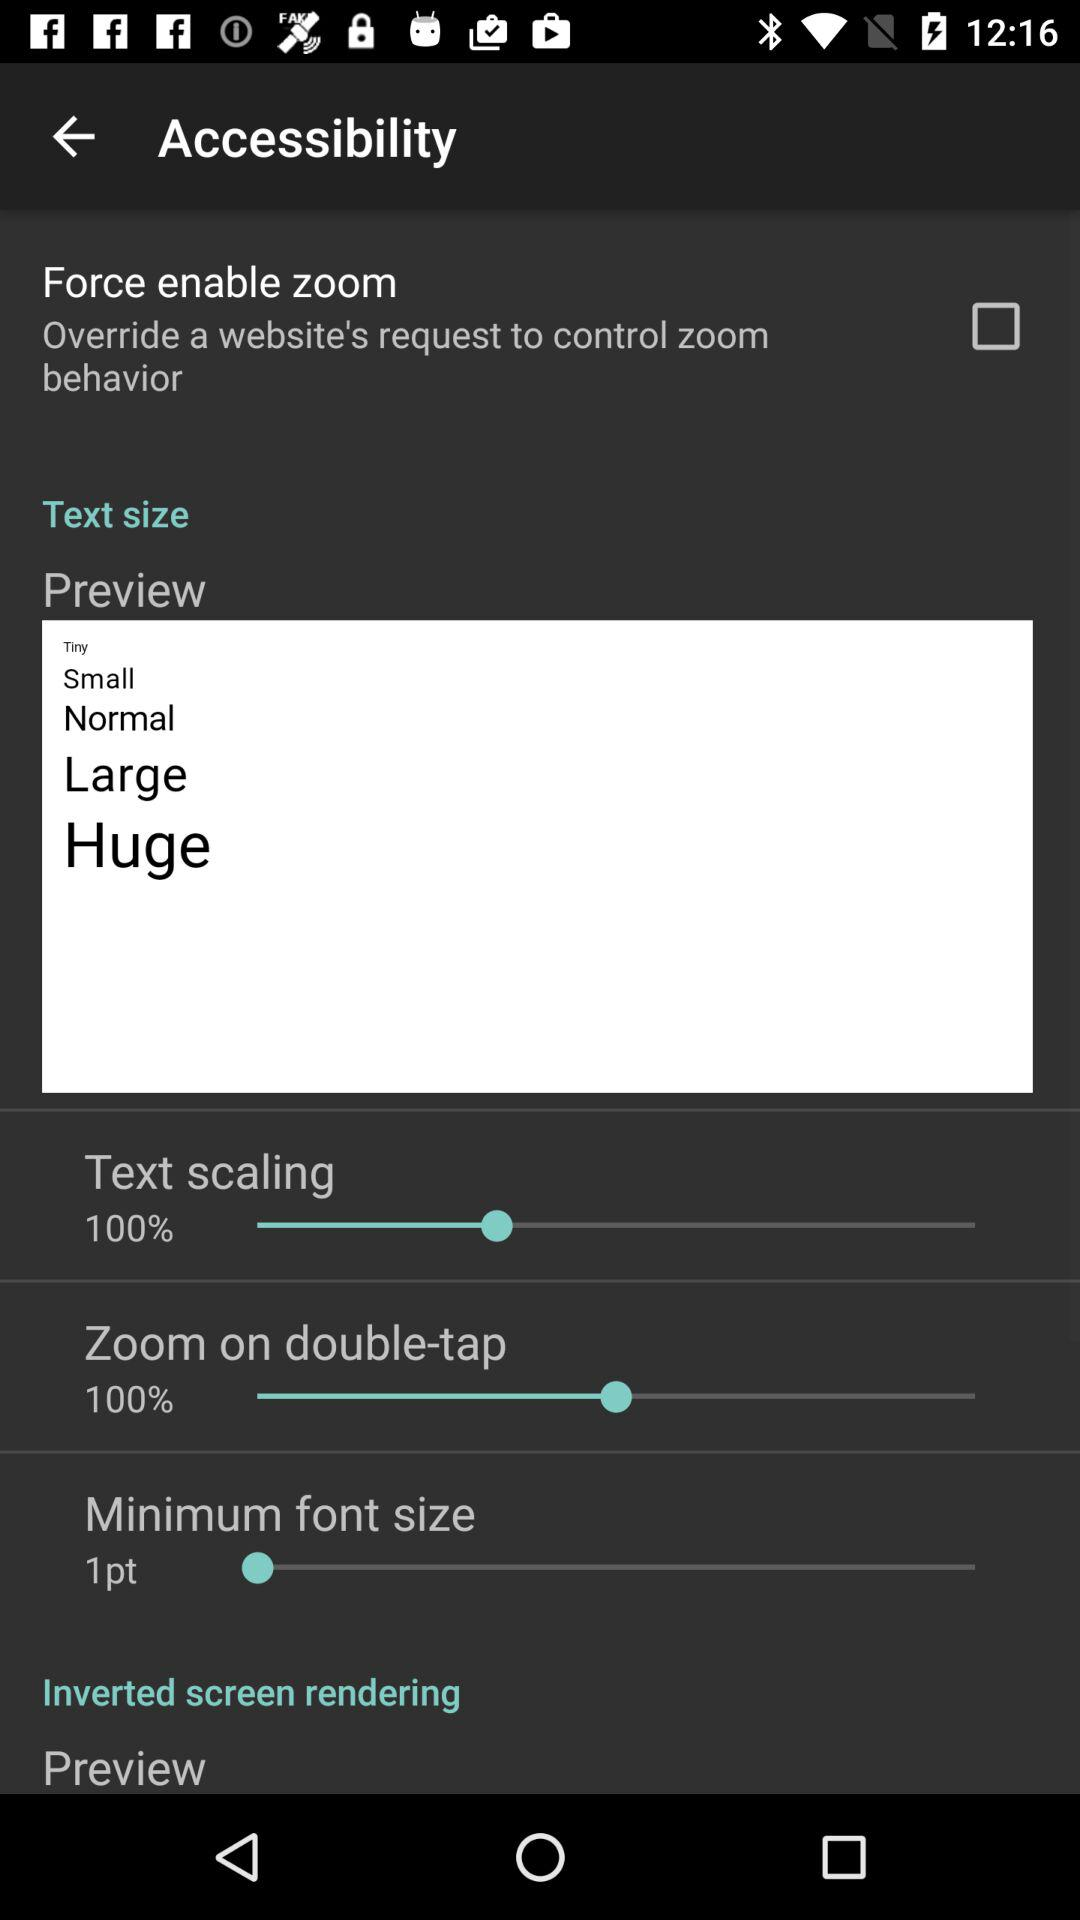What is the level of text scaling? The level of text scaling is 100%. 